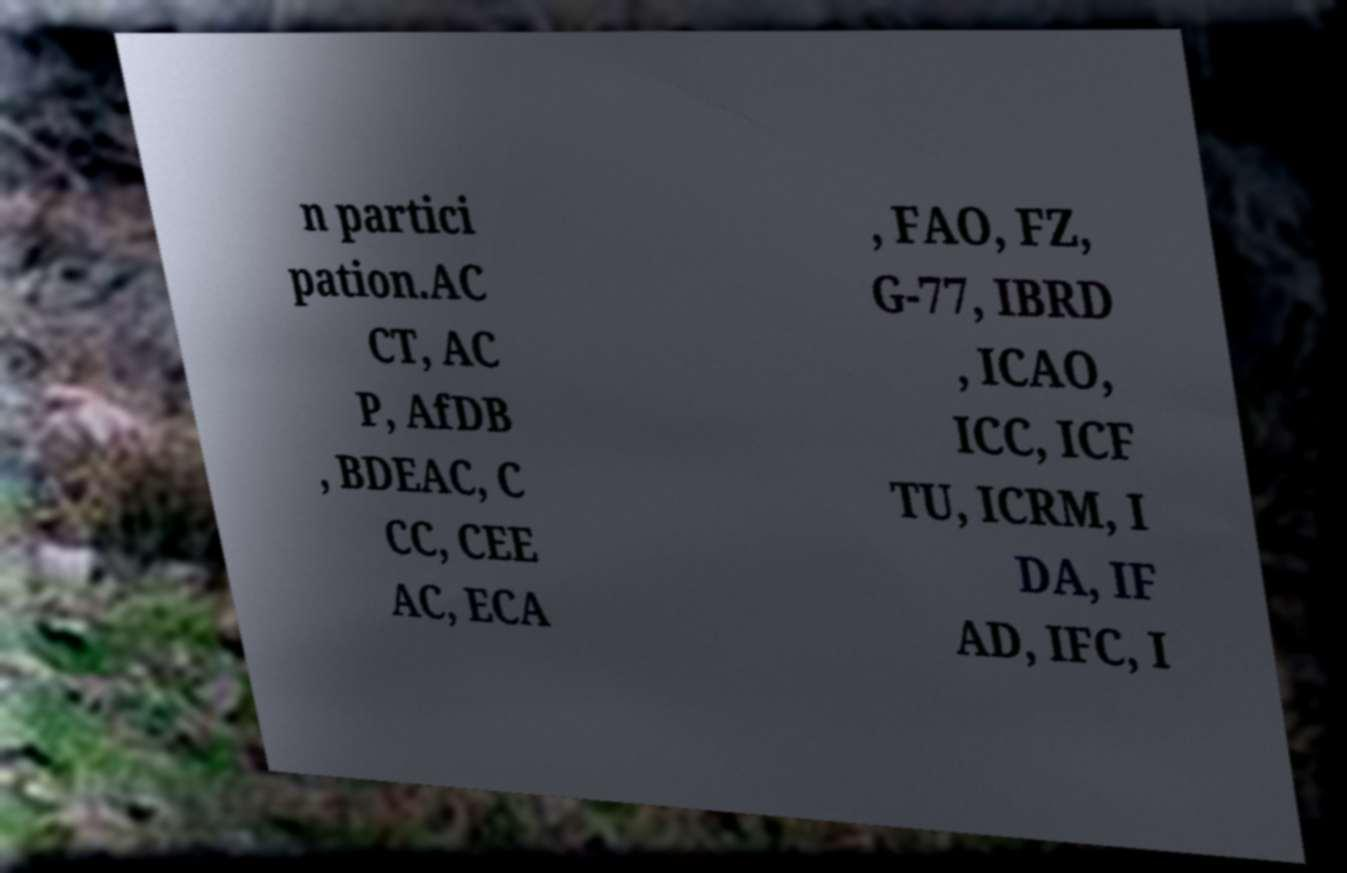What messages or text are displayed in this image? I need them in a readable, typed format. n partici pation.AC CT, AC P, AfDB , BDEAC, C CC, CEE AC, ECA , FAO, FZ, G-77, IBRD , ICAO, ICC, ICF TU, ICRM, I DA, IF AD, IFC, I 